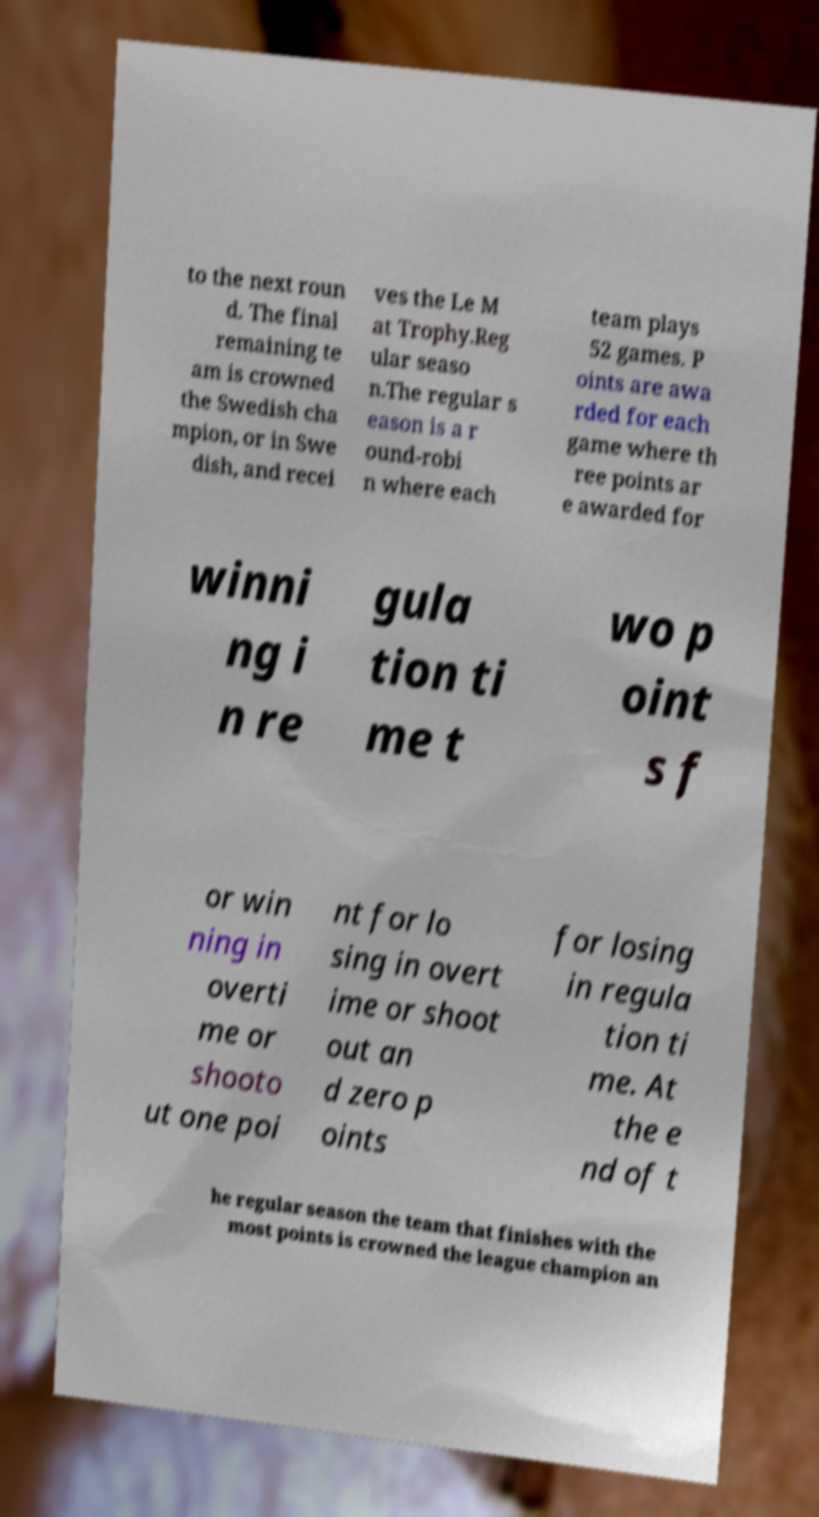What messages or text are displayed in this image? I need them in a readable, typed format. to the next roun d. The final remaining te am is crowned the Swedish cha mpion, or in Swe dish, and recei ves the Le M at Trophy.Reg ular seaso n.The regular s eason is a r ound-robi n where each team plays 52 games. P oints are awa rded for each game where th ree points ar e awarded for winni ng i n re gula tion ti me t wo p oint s f or win ning in overti me or shooto ut one poi nt for lo sing in overt ime or shoot out an d zero p oints for losing in regula tion ti me. At the e nd of t he regular season the team that finishes with the most points is crowned the league champion an 